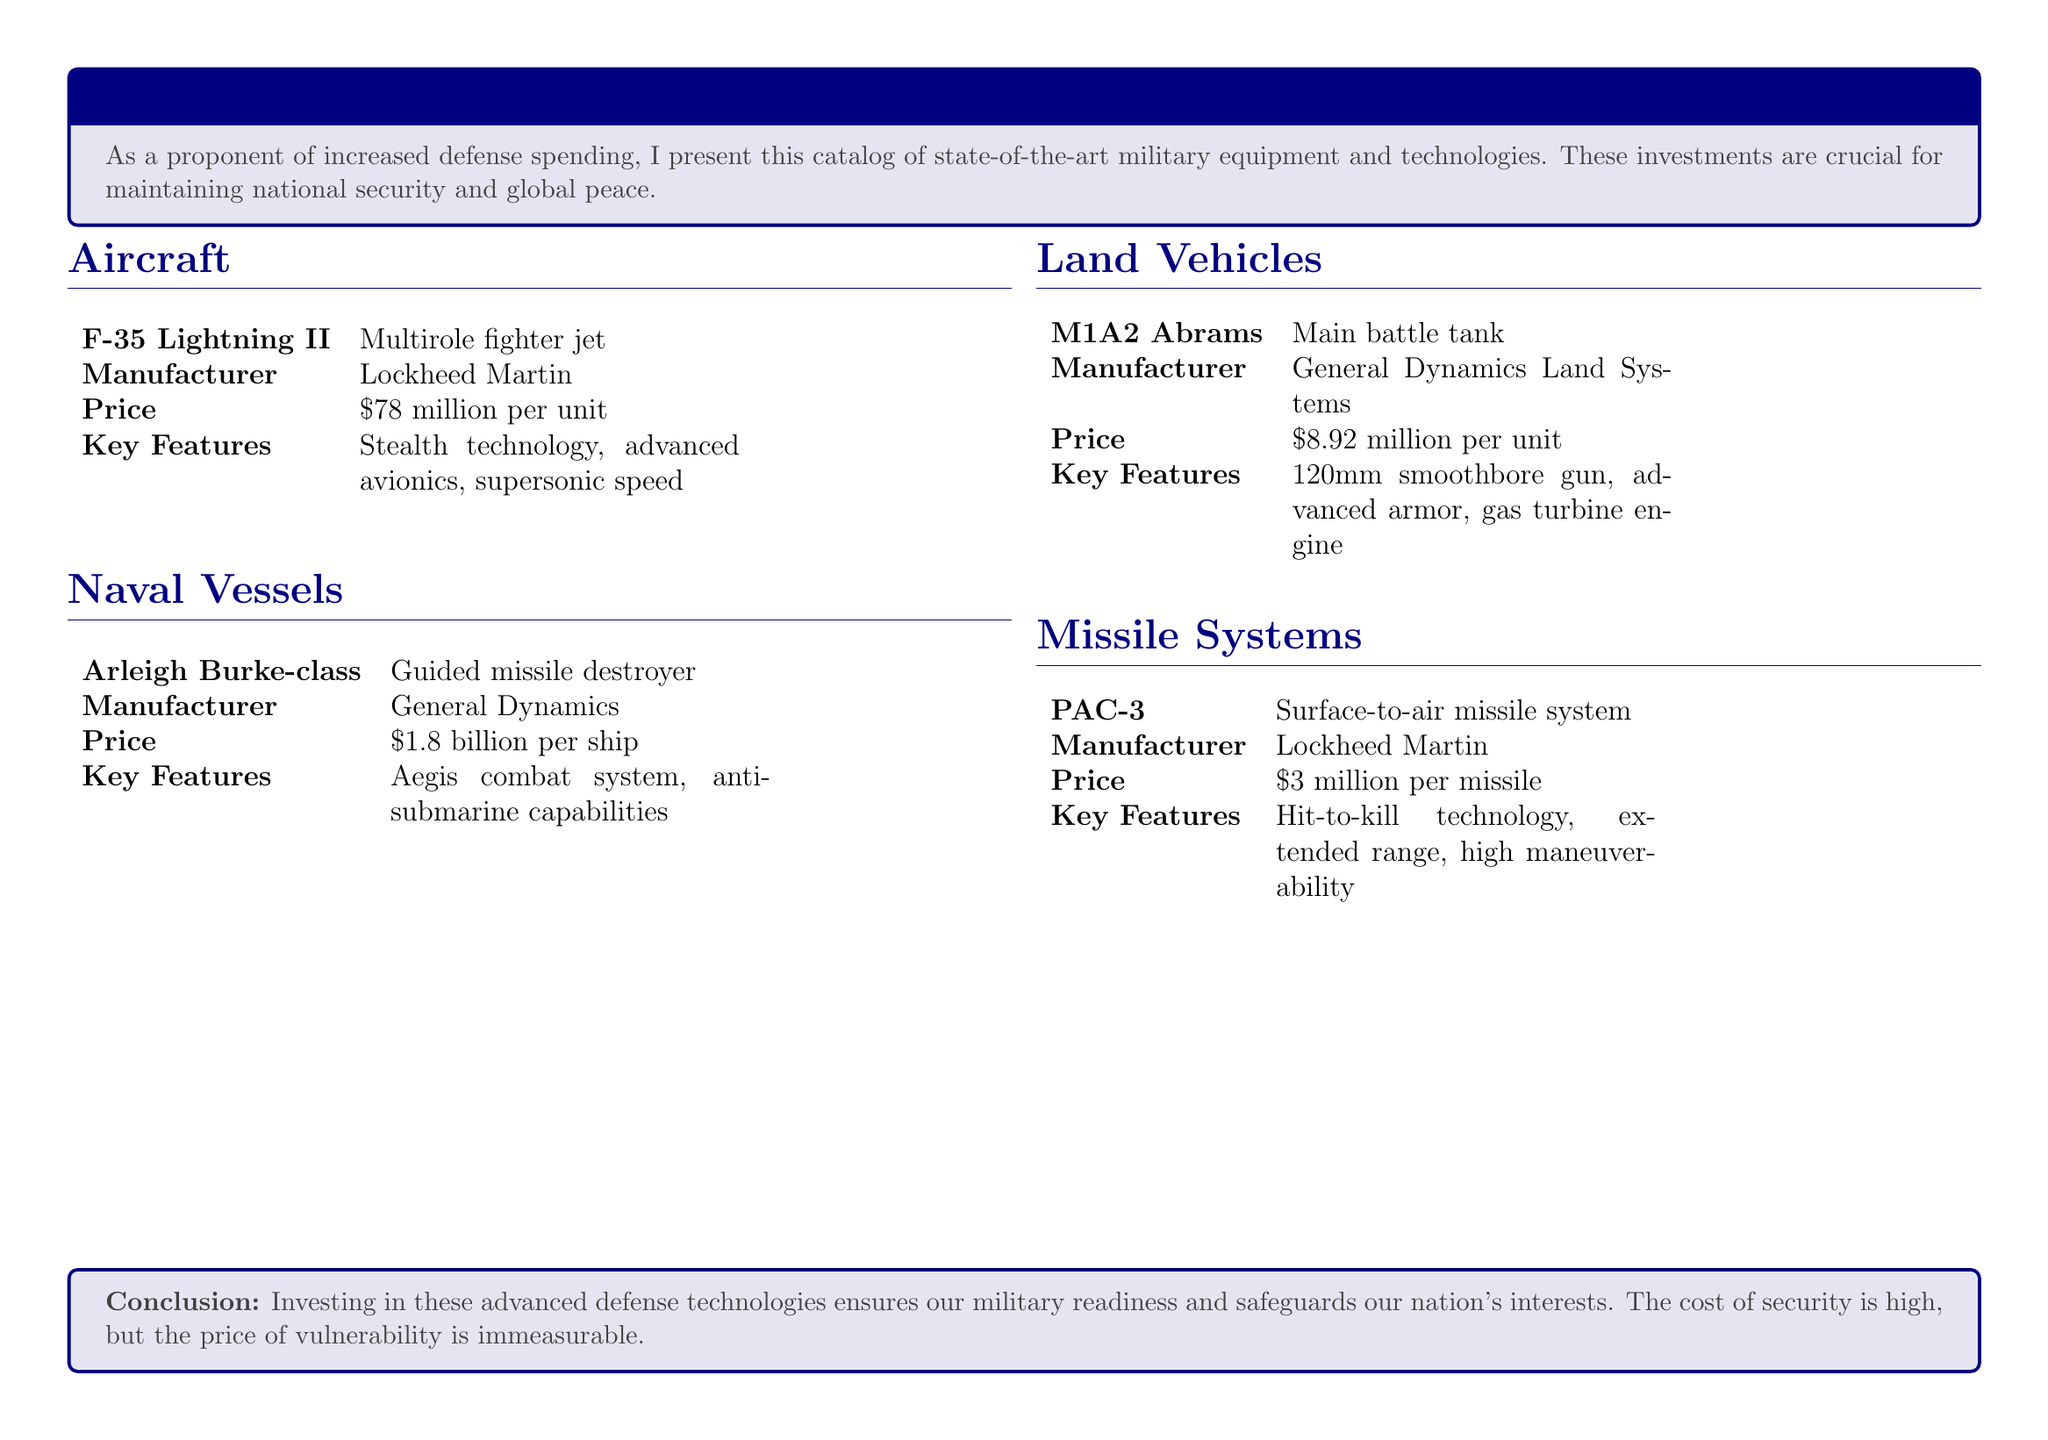What is the price of the F-35 Lightning II? The price is specified in the document as $78 million per unit.
Answer: $78 million per unit Who is the manufacturer of the M1A2 Abrams? The document states that General Dynamics Land Systems is the manufacturer.
Answer: General Dynamics Land Systems What are the key features of the Arleigh Burke-class? The document highlights the Aegis combat system and anti-submarine capabilities as key features.
Answer: Aegis combat system, anti-submarine capabilities How much does a PAC-3 missile cost? The catalog lists the cost of a PAC-3 missile as $3 million.
Answer: $3 million Which type of military vehicle is the M1A2 Abrams? The document identifies the M1A2 Abrams as a main battle tank.
Answer: Main battle tank What is the total price of one Arleigh Burke-class ship? The price is provided in the document as $1.8 billion.
Answer: $1.8 billion How many key features are listed for the F-35 Lightning II? The document outlines three key features for the F-35 Lightning II.
Answer: Three What type of document is this? It is presented as a catalog of military equipment and defense technologies.
Answer: Catalog What is emphasized as important for national security in the conclusion? The conclusion emphasizes investing in advanced defense technologies as crucial for military readiness.
Answer: Military readiness 